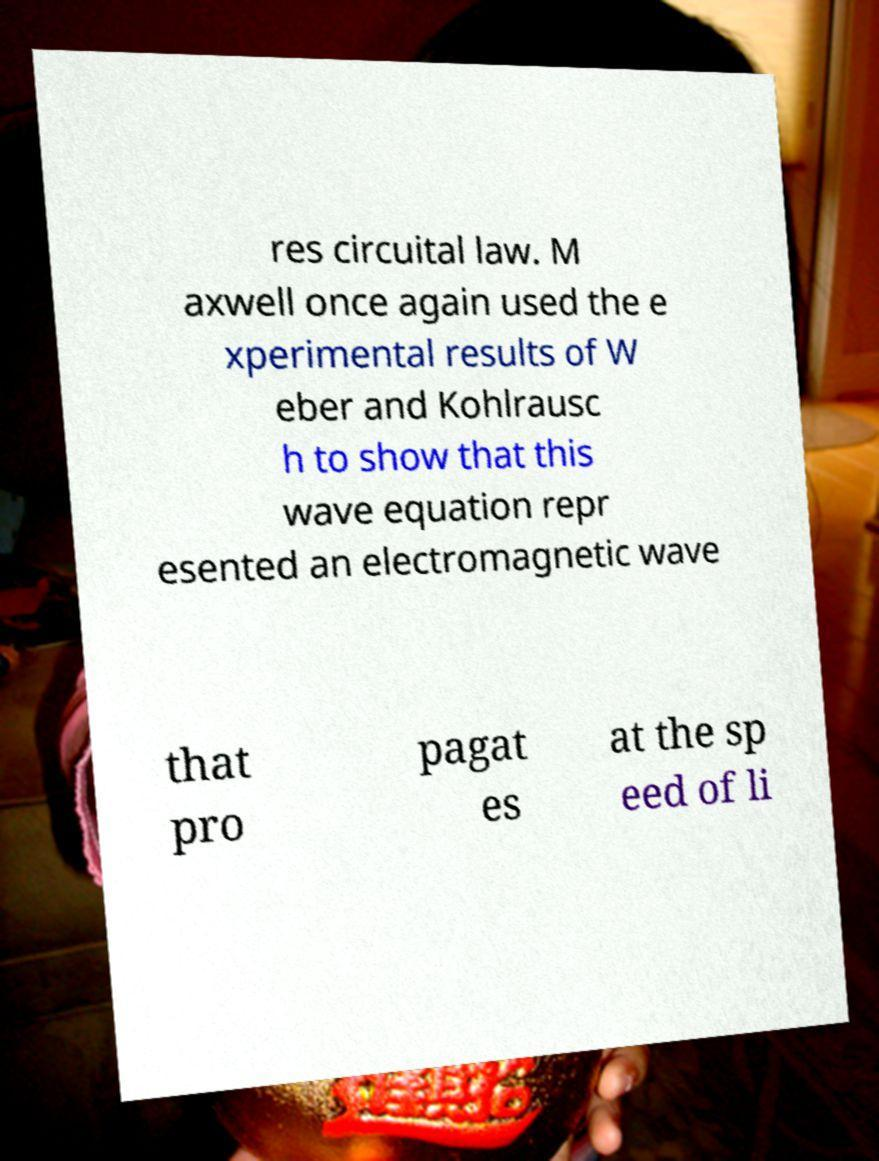I need the written content from this picture converted into text. Can you do that? res circuital law. M axwell once again used the e xperimental results of W eber and Kohlrausc h to show that this wave equation repr esented an electromagnetic wave that pro pagat es at the sp eed of li 